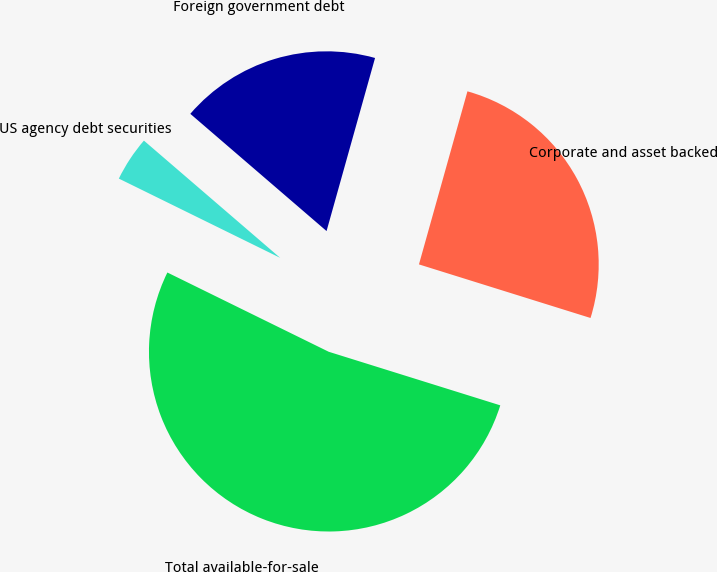Convert chart to OTSL. <chart><loc_0><loc_0><loc_500><loc_500><pie_chart><fcel>Corporate and asset backed<fcel>Foreign government debt<fcel>US agency debt securities<fcel>Total available-for-sale<nl><fcel>25.47%<fcel>18.04%<fcel>4.04%<fcel>52.45%<nl></chart> 